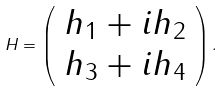Convert formula to latex. <formula><loc_0><loc_0><loc_500><loc_500>H = \left ( \begin{array} { c } h _ { 1 } + i h _ { 2 } \\ h _ { 3 } + i h _ { 4 } \end{array} \right ) .</formula> 